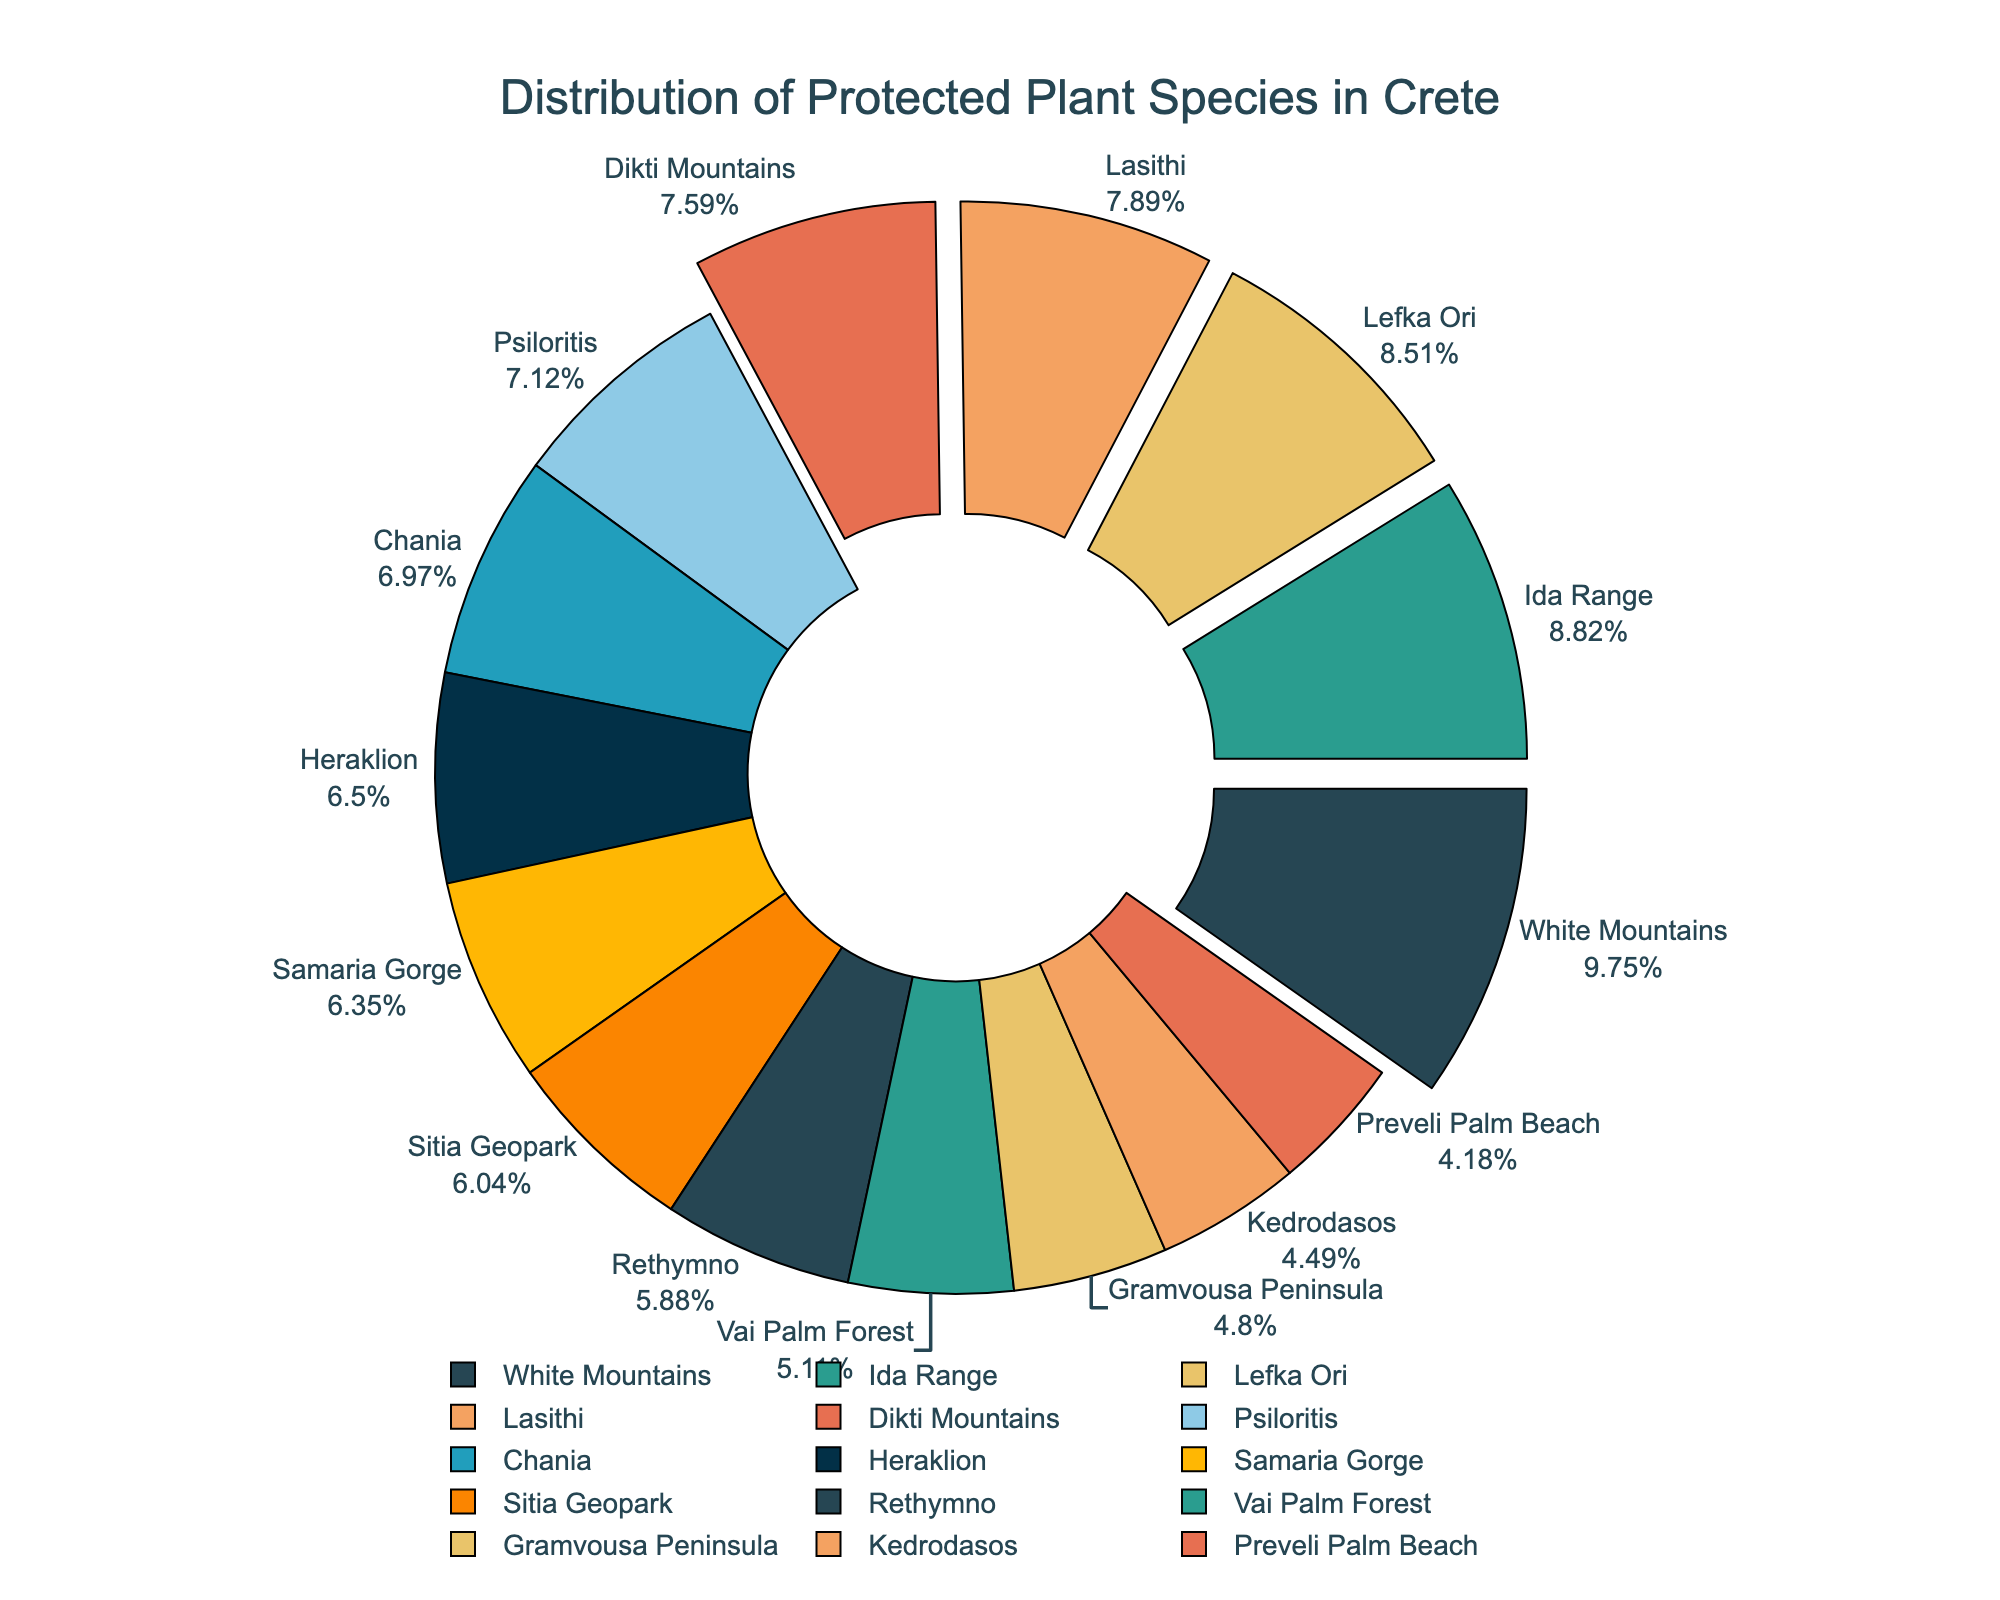Which region has the highest number of protected plant species? The region with the highest value will be the largest segment in the pie chart.
Answer: White Mountains Which region has the lowest number of protected plant species? The region with the lowest value will be the smallest segment in the pie chart.
Answer: Preveli Palm Beach How many protected plant species are there in the Lasithi region? Locate the segment labeled "Lasithi" and refer to its numerical value.
Answer: 51 What is the combined percentage of protected plant species in Chania and Heraklion? Add the percentage values of the segments labeled "Chania" and "Heraklion".
Answer: (check plot for actual percentage) Which regions have more protected plant species than Heraklion? Compare the numerical values of each region with those of "Heraklion" and identify the regions with higher values.
Answer: White Mountains, Ida Range, Dikti Mountains, Lefka Ori, Psiloritis, Lasithi Is the number of protected plant species in Samaria Gorge closer to that in Heraklion or Rethymno? Compare the numerical value of "Samaria Gorge" with those of "Heraklion" and "Rethymno" and see which one is closer.
Answer: Rethymno What is the total number of protected plant species in Ida Range and Dikti Mountains combined? Add the numerical values of "Ida Range" and "Dikti Mountains".
Answer: 106 Which region occupies the largest space in the pie chart? Identify the region represented by the largest segment visually.
Answer: White Mountains Which regions' segments are pulled out slightly from the pie chart? Observe the pie segments that are visually separated or pulled out further from the center.
Answer: White Mountains, Ida Range, Dikti Mountains, Lefka Ori, Psiloritis How does the number of protected plant species in Gramvousa Peninsula compare to that in Sitia Geopark? Compare the numerical values of "Gramvousa Peninsula" and "Sitia Geopark".
Answer: Gramvousa Peninsula has fewer species than Sitia Geopark 